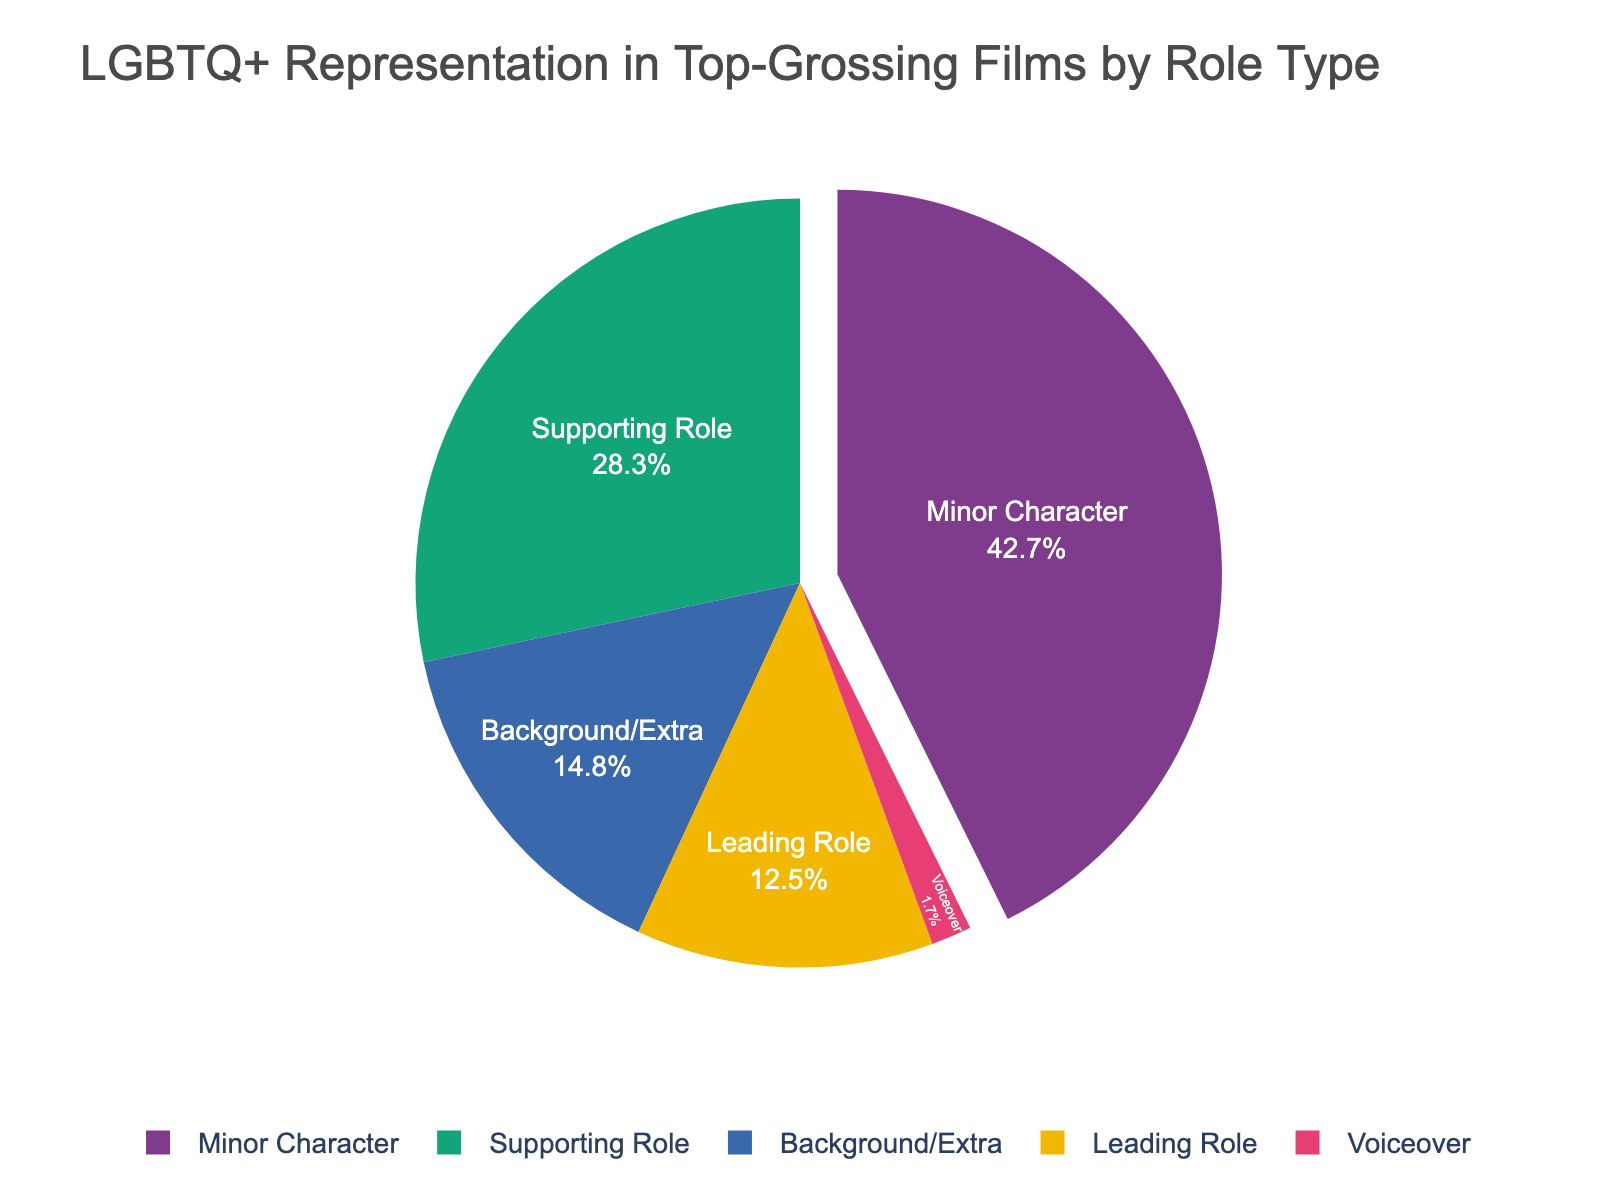What percentage of LGBTQ+ characters in top-grossing films are in background/extra roles? The figure shows the percentage distribution of LGBTQ+ characters by role type in a pie chart. Look at the section labeled 'Background/Extra' and read the corresponding percentage.
Answer: 14.8% Which role type has the highest percentage of LGBTQ+ characters, and what is that percentage? Identify the largest segment in the pie chart and note the label and percentage associated with it.
Answer: Minor Character, 42.7% What is the combined percentage of LGBTQ+ characters in leading and supporting roles? Add the percentage of 'Leading Role' and 'Supporting Role' from the pie chart. 12.5% (Leading Role) + 28.3% (Supporting Role) = 40.8%
Answer: 40.8% How much greater is the percentage of LGBTQ+ characters in supporting roles compared to background/extra roles? Subtract the percentage of 'Background/Extra' from 'Supporting Role'. 28.3% (Supporting Role) - 14.8% (Background/Extra) = 13.5%
Answer: 13.5% Which role type has the least representation of LGBTQ+ characters, and what is the percentage? Identify the smallest segment in the pie chart and note the role type and its percentage.
Answer: Voiceover, 1.7% Are there more LGBTQ+ characters in minor roles than in leading and supporting roles combined? Compare the percentage of 'Minor Character' with the combined percentage of 'Leading Role' and 'Supporting Role'. Minor Character is 42.7%, Leading Role + Supporting Role is 40.8%. Since 42.7% > 40.8%, the answer is yes.
Answer: Yes By how much does the percentage of LGBTQ+ characters in minor roles exceed those in leading roles? Subtract the percentage of 'Leading Role' from 'Minor Character'. 42.7% (Minor Character) - 12.5% (Leading Role) = 30.2%
Answer: 30.2% What is the second most common role type for LGBTQ+ characters, and what percentage of the total does it represent? Identify the second largest segment in the pie chart and note the role type and its percentage.
Answer: Supporting Role, 28.3% 